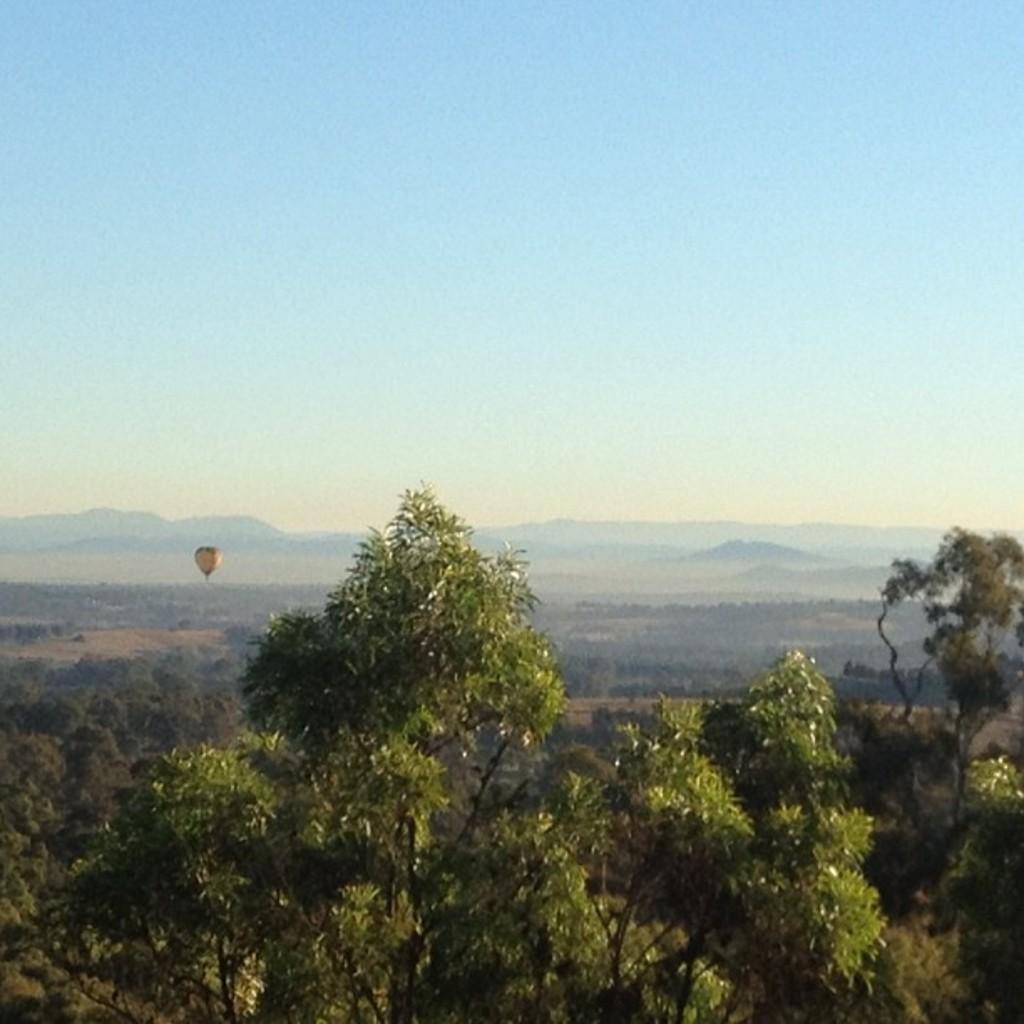In one or two sentences, can you explain what this image depicts? In this picture I can see trees and hot air balloon and I can see hills in the back and I can see blue sky. 